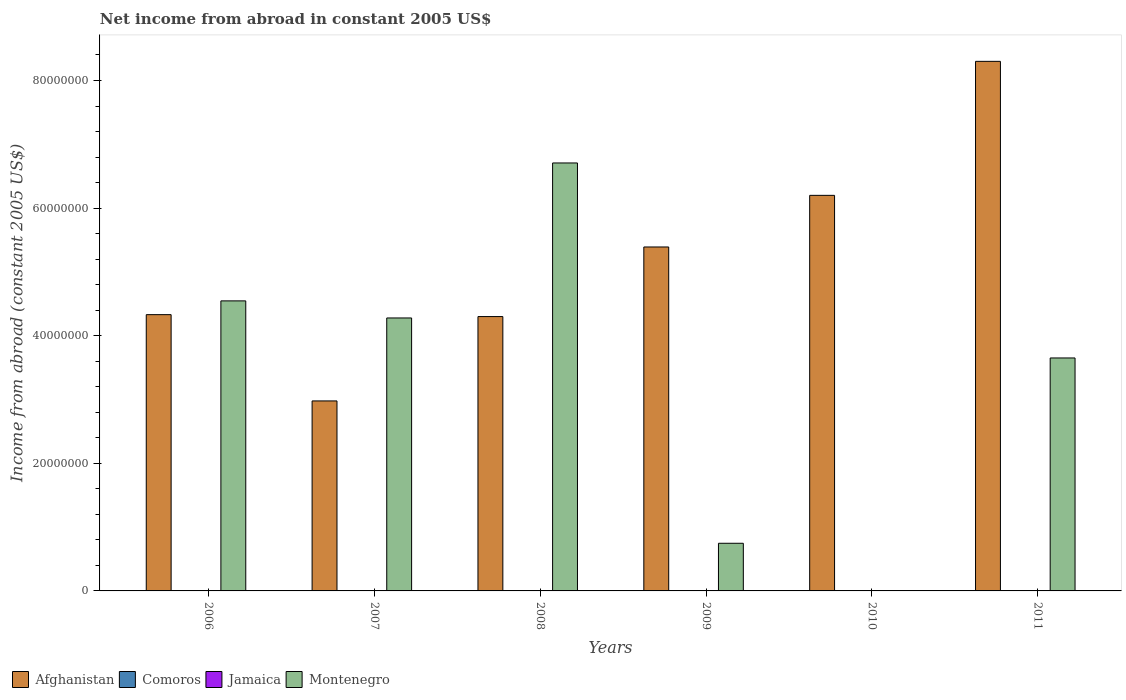How many bars are there on the 2nd tick from the left?
Your answer should be compact. 2. What is the net income from abroad in Afghanistan in 2006?
Ensure brevity in your answer.  4.33e+07. Across all years, what is the maximum net income from abroad in Montenegro?
Provide a succinct answer. 6.71e+07. In which year was the net income from abroad in Afghanistan maximum?
Your answer should be compact. 2011. What is the total net income from abroad in Comoros in the graph?
Offer a terse response. 0. What is the difference between the net income from abroad in Montenegro in 2008 and that in 2009?
Ensure brevity in your answer.  5.96e+07. In the year 2009, what is the difference between the net income from abroad in Montenegro and net income from abroad in Afghanistan?
Offer a very short reply. -4.64e+07. In how many years, is the net income from abroad in Jamaica greater than 20000000 US$?
Ensure brevity in your answer.  0. What is the ratio of the net income from abroad in Montenegro in 2006 to that in 2008?
Ensure brevity in your answer.  0.68. Is the net income from abroad in Montenegro in 2007 less than that in 2009?
Provide a short and direct response. No. What is the difference between the highest and the second highest net income from abroad in Afghanistan?
Offer a very short reply. 2.10e+07. What is the difference between the highest and the lowest net income from abroad in Montenegro?
Your answer should be very brief. 6.71e+07. Is it the case that in every year, the sum of the net income from abroad in Montenegro and net income from abroad in Afghanistan is greater than the sum of net income from abroad in Comoros and net income from abroad in Jamaica?
Provide a short and direct response. No. Are all the bars in the graph horizontal?
Provide a succinct answer. No. Are the values on the major ticks of Y-axis written in scientific E-notation?
Provide a succinct answer. No. Does the graph contain grids?
Offer a terse response. No. Where does the legend appear in the graph?
Keep it short and to the point. Bottom left. What is the title of the graph?
Your response must be concise. Net income from abroad in constant 2005 US$. Does "Low income" appear as one of the legend labels in the graph?
Your answer should be compact. No. What is the label or title of the Y-axis?
Provide a short and direct response. Income from abroad (constant 2005 US$). What is the Income from abroad (constant 2005 US$) of Afghanistan in 2006?
Offer a terse response. 4.33e+07. What is the Income from abroad (constant 2005 US$) in Comoros in 2006?
Your answer should be compact. 0. What is the Income from abroad (constant 2005 US$) of Jamaica in 2006?
Provide a succinct answer. 0. What is the Income from abroad (constant 2005 US$) in Montenegro in 2006?
Give a very brief answer. 4.55e+07. What is the Income from abroad (constant 2005 US$) in Afghanistan in 2007?
Ensure brevity in your answer.  2.98e+07. What is the Income from abroad (constant 2005 US$) of Jamaica in 2007?
Ensure brevity in your answer.  0. What is the Income from abroad (constant 2005 US$) in Montenegro in 2007?
Provide a short and direct response. 4.28e+07. What is the Income from abroad (constant 2005 US$) of Afghanistan in 2008?
Your response must be concise. 4.30e+07. What is the Income from abroad (constant 2005 US$) in Jamaica in 2008?
Ensure brevity in your answer.  0. What is the Income from abroad (constant 2005 US$) in Montenegro in 2008?
Ensure brevity in your answer.  6.71e+07. What is the Income from abroad (constant 2005 US$) of Afghanistan in 2009?
Provide a short and direct response. 5.39e+07. What is the Income from abroad (constant 2005 US$) in Comoros in 2009?
Your answer should be compact. 0. What is the Income from abroad (constant 2005 US$) of Montenegro in 2009?
Provide a short and direct response. 7.47e+06. What is the Income from abroad (constant 2005 US$) of Afghanistan in 2010?
Your answer should be very brief. 6.20e+07. What is the Income from abroad (constant 2005 US$) in Montenegro in 2010?
Ensure brevity in your answer.  0. What is the Income from abroad (constant 2005 US$) of Afghanistan in 2011?
Offer a terse response. 8.30e+07. What is the Income from abroad (constant 2005 US$) in Montenegro in 2011?
Your answer should be very brief. 3.65e+07. Across all years, what is the maximum Income from abroad (constant 2005 US$) in Afghanistan?
Offer a terse response. 8.30e+07. Across all years, what is the maximum Income from abroad (constant 2005 US$) of Montenegro?
Give a very brief answer. 6.71e+07. Across all years, what is the minimum Income from abroad (constant 2005 US$) in Afghanistan?
Your answer should be compact. 2.98e+07. What is the total Income from abroad (constant 2005 US$) of Afghanistan in the graph?
Provide a succinct answer. 3.15e+08. What is the total Income from abroad (constant 2005 US$) of Jamaica in the graph?
Keep it short and to the point. 0. What is the total Income from abroad (constant 2005 US$) of Montenegro in the graph?
Your answer should be very brief. 1.99e+08. What is the difference between the Income from abroad (constant 2005 US$) of Afghanistan in 2006 and that in 2007?
Give a very brief answer. 1.35e+07. What is the difference between the Income from abroad (constant 2005 US$) in Montenegro in 2006 and that in 2007?
Offer a terse response. 2.68e+06. What is the difference between the Income from abroad (constant 2005 US$) in Afghanistan in 2006 and that in 2008?
Your answer should be compact. 3.04e+05. What is the difference between the Income from abroad (constant 2005 US$) of Montenegro in 2006 and that in 2008?
Make the answer very short. -2.16e+07. What is the difference between the Income from abroad (constant 2005 US$) in Afghanistan in 2006 and that in 2009?
Your answer should be compact. -1.06e+07. What is the difference between the Income from abroad (constant 2005 US$) of Montenegro in 2006 and that in 2009?
Make the answer very short. 3.80e+07. What is the difference between the Income from abroad (constant 2005 US$) of Afghanistan in 2006 and that in 2010?
Offer a very short reply. -1.87e+07. What is the difference between the Income from abroad (constant 2005 US$) in Afghanistan in 2006 and that in 2011?
Offer a terse response. -3.97e+07. What is the difference between the Income from abroad (constant 2005 US$) in Montenegro in 2006 and that in 2011?
Offer a terse response. 8.95e+06. What is the difference between the Income from abroad (constant 2005 US$) of Afghanistan in 2007 and that in 2008?
Your answer should be very brief. -1.32e+07. What is the difference between the Income from abroad (constant 2005 US$) in Montenegro in 2007 and that in 2008?
Provide a succinct answer. -2.43e+07. What is the difference between the Income from abroad (constant 2005 US$) in Afghanistan in 2007 and that in 2009?
Keep it short and to the point. -2.41e+07. What is the difference between the Income from abroad (constant 2005 US$) of Montenegro in 2007 and that in 2009?
Offer a terse response. 3.53e+07. What is the difference between the Income from abroad (constant 2005 US$) of Afghanistan in 2007 and that in 2010?
Your answer should be very brief. -3.22e+07. What is the difference between the Income from abroad (constant 2005 US$) of Afghanistan in 2007 and that in 2011?
Make the answer very short. -5.32e+07. What is the difference between the Income from abroad (constant 2005 US$) in Montenegro in 2007 and that in 2011?
Keep it short and to the point. 6.27e+06. What is the difference between the Income from abroad (constant 2005 US$) in Afghanistan in 2008 and that in 2009?
Your answer should be compact. -1.09e+07. What is the difference between the Income from abroad (constant 2005 US$) of Montenegro in 2008 and that in 2009?
Your answer should be very brief. 5.96e+07. What is the difference between the Income from abroad (constant 2005 US$) in Afghanistan in 2008 and that in 2010?
Give a very brief answer. -1.90e+07. What is the difference between the Income from abroad (constant 2005 US$) of Afghanistan in 2008 and that in 2011?
Provide a short and direct response. -4.00e+07. What is the difference between the Income from abroad (constant 2005 US$) in Montenegro in 2008 and that in 2011?
Give a very brief answer. 3.06e+07. What is the difference between the Income from abroad (constant 2005 US$) of Afghanistan in 2009 and that in 2010?
Your answer should be compact. -8.09e+06. What is the difference between the Income from abroad (constant 2005 US$) of Afghanistan in 2009 and that in 2011?
Your response must be concise. -2.91e+07. What is the difference between the Income from abroad (constant 2005 US$) of Montenegro in 2009 and that in 2011?
Give a very brief answer. -2.90e+07. What is the difference between the Income from abroad (constant 2005 US$) of Afghanistan in 2010 and that in 2011?
Make the answer very short. -2.10e+07. What is the difference between the Income from abroad (constant 2005 US$) of Afghanistan in 2006 and the Income from abroad (constant 2005 US$) of Montenegro in 2007?
Keep it short and to the point. 5.19e+05. What is the difference between the Income from abroad (constant 2005 US$) of Afghanistan in 2006 and the Income from abroad (constant 2005 US$) of Montenegro in 2008?
Your answer should be compact. -2.38e+07. What is the difference between the Income from abroad (constant 2005 US$) of Afghanistan in 2006 and the Income from abroad (constant 2005 US$) of Montenegro in 2009?
Keep it short and to the point. 3.58e+07. What is the difference between the Income from abroad (constant 2005 US$) in Afghanistan in 2006 and the Income from abroad (constant 2005 US$) in Montenegro in 2011?
Your answer should be compact. 6.79e+06. What is the difference between the Income from abroad (constant 2005 US$) in Afghanistan in 2007 and the Income from abroad (constant 2005 US$) in Montenegro in 2008?
Your answer should be very brief. -3.73e+07. What is the difference between the Income from abroad (constant 2005 US$) in Afghanistan in 2007 and the Income from abroad (constant 2005 US$) in Montenegro in 2009?
Your answer should be very brief. 2.23e+07. What is the difference between the Income from abroad (constant 2005 US$) in Afghanistan in 2007 and the Income from abroad (constant 2005 US$) in Montenegro in 2011?
Provide a succinct answer. -6.73e+06. What is the difference between the Income from abroad (constant 2005 US$) of Afghanistan in 2008 and the Income from abroad (constant 2005 US$) of Montenegro in 2009?
Your answer should be compact. 3.55e+07. What is the difference between the Income from abroad (constant 2005 US$) in Afghanistan in 2008 and the Income from abroad (constant 2005 US$) in Montenegro in 2011?
Your answer should be very brief. 6.49e+06. What is the difference between the Income from abroad (constant 2005 US$) in Afghanistan in 2009 and the Income from abroad (constant 2005 US$) in Montenegro in 2011?
Give a very brief answer. 1.74e+07. What is the difference between the Income from abroad (constant 2005 US$) of Afghanistan in 2010 and the Income from abroad (constant 2005 US$) of Montenegro in 2011?
Offer a terse response. 2.55e+07. What is the average Income from abroad (constant 2005 US$) in Afghanistan per year?
Offer a very short reply. 5.25e+07. What is the average Income from abroad (constant 2005 US$) in Comoros per year?
Ensure brevity in your answer.  0. What is the average Income from abroad (constant 2005 US$) in Montenegro per year?
Offer a terse response. 3.32e+07. In the year 2006, what is the difference between the Income from abroad (constant 2005 US$) of Afghanistan and Income from abroad (constant 2005 US$) of Montenegro?
Your response must be concise. -2.16e+06. In the year 2007, what is the difference between the Income from abroad (constant 2005 US$) in Afghanistan and Income from abroad (constant 2005 US$) in Montenegro?
Offer a very short reply. -1.30e+07. In the year 2008, what is the difference between the Income from abroad (constant 2005 US$) in Afghanistan and Income from abroad (constant 2005 US$) in Montenegro?
Keep it short and to the point. -2.41e+07. In the year 2009, what is the difference between the Income from abroad (constant 2005 US$) of Afghanistan and Income from abroad (constant 2005 US$) of Montenegro?
Give a very brief answer. 4.64e+07. In the year 2011, what is the difference between the Income from abroad (constant 2005 US$) of Afghanistan and Income from abroad (constant 2005 US$) of Montenegro?
Provide a succinct answer. 4.65e+07. What is the ratio of the Income from abroad (constant 2005 US$) in Afghanistan in 2006 to that in 2007?
Your answer should be compact. 1.45. What is the ratio of the Income from abroad (constant 2005 US$) in Afghanistan in 2006 to that in 2008?
Give a very brief answer. 1.01. What is the ratio of the Income from abroad (constant 2005 US$) of Montenegro in 2006 to that in 2008?
Your response must be concise. 0.68. What is the ratio of the Income from abroad (constant 2005 US$) of Afghanistan in 2006 to that in 2009?
Keep it short and to the point. 0.8. What is the ratio of the Income from abroad (constant 2005 US$) in Montenegro in 2006 to that in 2009?
Offer a very short reply. 6.09. What is the ratio of the Income from abroad (constant 2005 US$) of Afghanistan in 2006 to that in 2010?
Offer a terse response. 0.7. What is the ratio of the Income from abroad (constant 2005 US$) in Afghanistan in 2006 to that in 2011?
Make the answer very short. 0.52. What is the ratio of the Income from abroad (constant 2005 US$) in Montenegro in 2006 to that in 2011?
Provide a short and direct response. 1.25. What is the ratio of the Income from abroad (constant 2005 US$) of Afghanistan in 2007 to that in 2008?
Make the answer very short. 0.69. What is the ratio of the Income from abroad (constant 2005 US$) of Montenegro in 2007 to that in 2008?
Offer a very short reply. 0.64. What is the ratio of the Income from abroad (constant 2005 US$) of Afghanistan in 2007 to that in 2009?
Your answer should be compact. 0.55. What is the ratio of the Income from abroad (constant 2005 US$) in Montenegro in 2007 to that in 2009?
Provide a succinct answer. 5.73. What is the ratio of the Income from abroad (constant 2005 US$) in Afghanistan in 2007 to that in 2010?
Your response must be concise. 0.48. What is the ratio of the Income from abroad (constant 2005 US$) in Afghanistan in 2007 to that in 2011?
Offer a very short reply. 0.36. What is the ratio of the Income from abroad (constant 2005 US$) of Montenegro in 2007 to that in 2011?
Your response must be concise. 1.17. What is the ratio of the Income from abroad (constant 2005 US$) in Afghanistan in 2008 to that in 2009?
Give a very brief answer. 0.8. What is the ratio of the Income from abroad (constant 2005 US$) of Montenegro in 2008 to that in 2009?
Your answer should be very brief. 8.98. What is the ratio of the Income from abroad (constant 2005 US$) of Afghanistan in 2008 to that in 2010?
Your answer should be very brief. 0.69. What is the ratio of the Income from abroad (constant 2005 US$) in Afghanistan in 2008 to that in 2011?
Provide a succinct answer. 0.52. What is the ratio of the Income from abroad (constant 2005 US$) of Montenegro in 2008 to that in 2011?
Offer a very short reply. 1.84. What is the ratio of the Income from abroad (constant 2005 US$) in Afghanistan in 2009 to that in 2010?
Provide a short and direct response. 0.87. What is the ratio of the Income from abroad (constant 2005 US$) of Afghanistan in 2009 to that in 2011?
Offer a terse response. 0.65. What is the ratio of the Income from abroad (constant 2005 US$) of Montenegro in 2009 to that in 2011?
Provide a short and direct response. 0.2. What is the ratio of the Income from abroad (constant 2005 US$) in Afghanistan in 2010 to that in 2011?
Offer a very short reply. 0.75. What is the difference between the highest and the second highest Income from abroad (constant 2005 US$) in Afghanistan?
Make the answer very short. 2.10e+07. What is the difference between the highest and the second highest Income from abroad (constant 2005 US$) in Montenegro?
Make the answer very short. 2.16e+07. What is the difference between the highest and the lowest Income from abroad (constant 2005 US$) in Afghanistan?
Keep it short and to the point. 5.32e+07. What is the difference between the highest and the lowest Income from abroad (constant 2005 US$) of Montenegro?
Your answer should be very brief. 6.71e+07. 